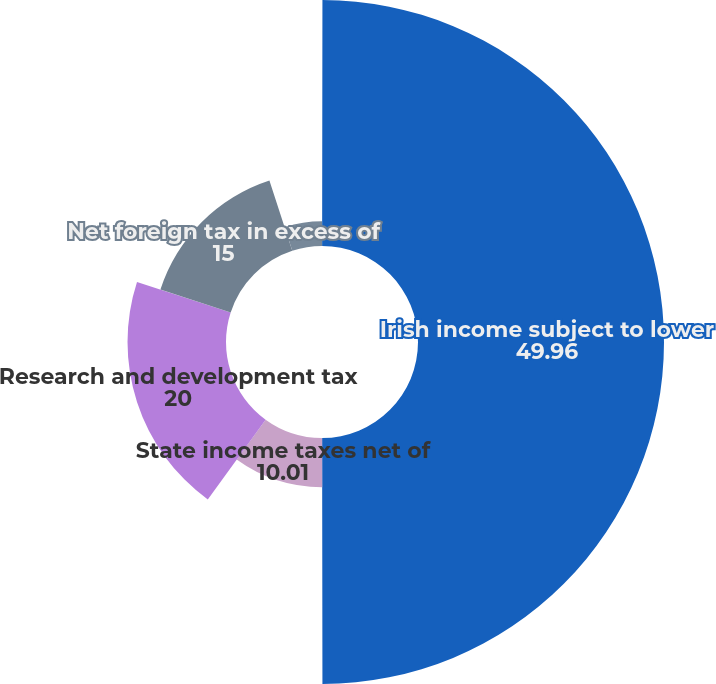<chart> <loc_0><loc_0><loc_500><loc_500><pie_chart><fcel>US federal statutory tax rate<fcel>Irish income subject to lower<fcel>State income taxes net of<fcel>Research and development tax<fcel>Net foreign tax in excess of<fcel>Other net<nl><fcel>0.02%<fcel>49.96%<fcel>10.01%<fcel>20.0%<fcel>15.0%<fcel>5.01%<nl></chart> 